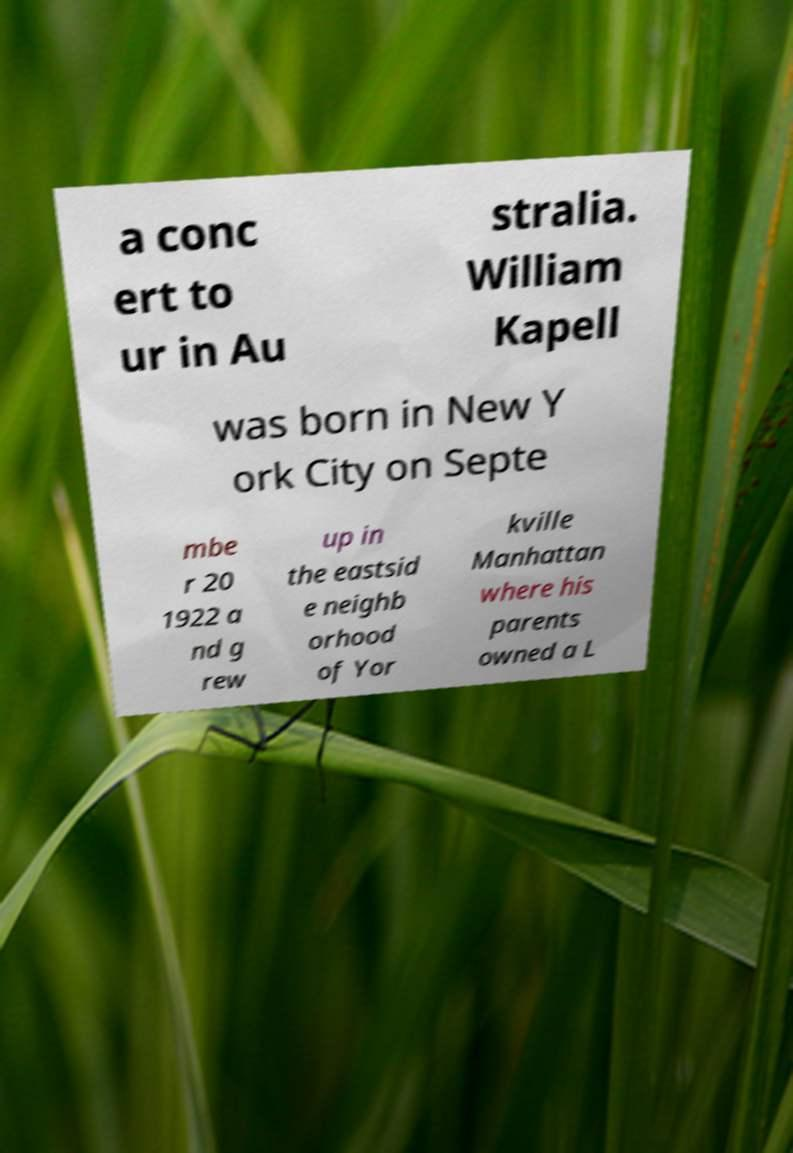Please read and relay the text visible in this image. What does it say? a conc ert to ur in Au stralia. William Kapell was born in New Y ork City on Septe mbe r 20 1922 a nd g rew up in the eastsid e neighb orhood of Yor kville Manhattan where his parents owned a L 